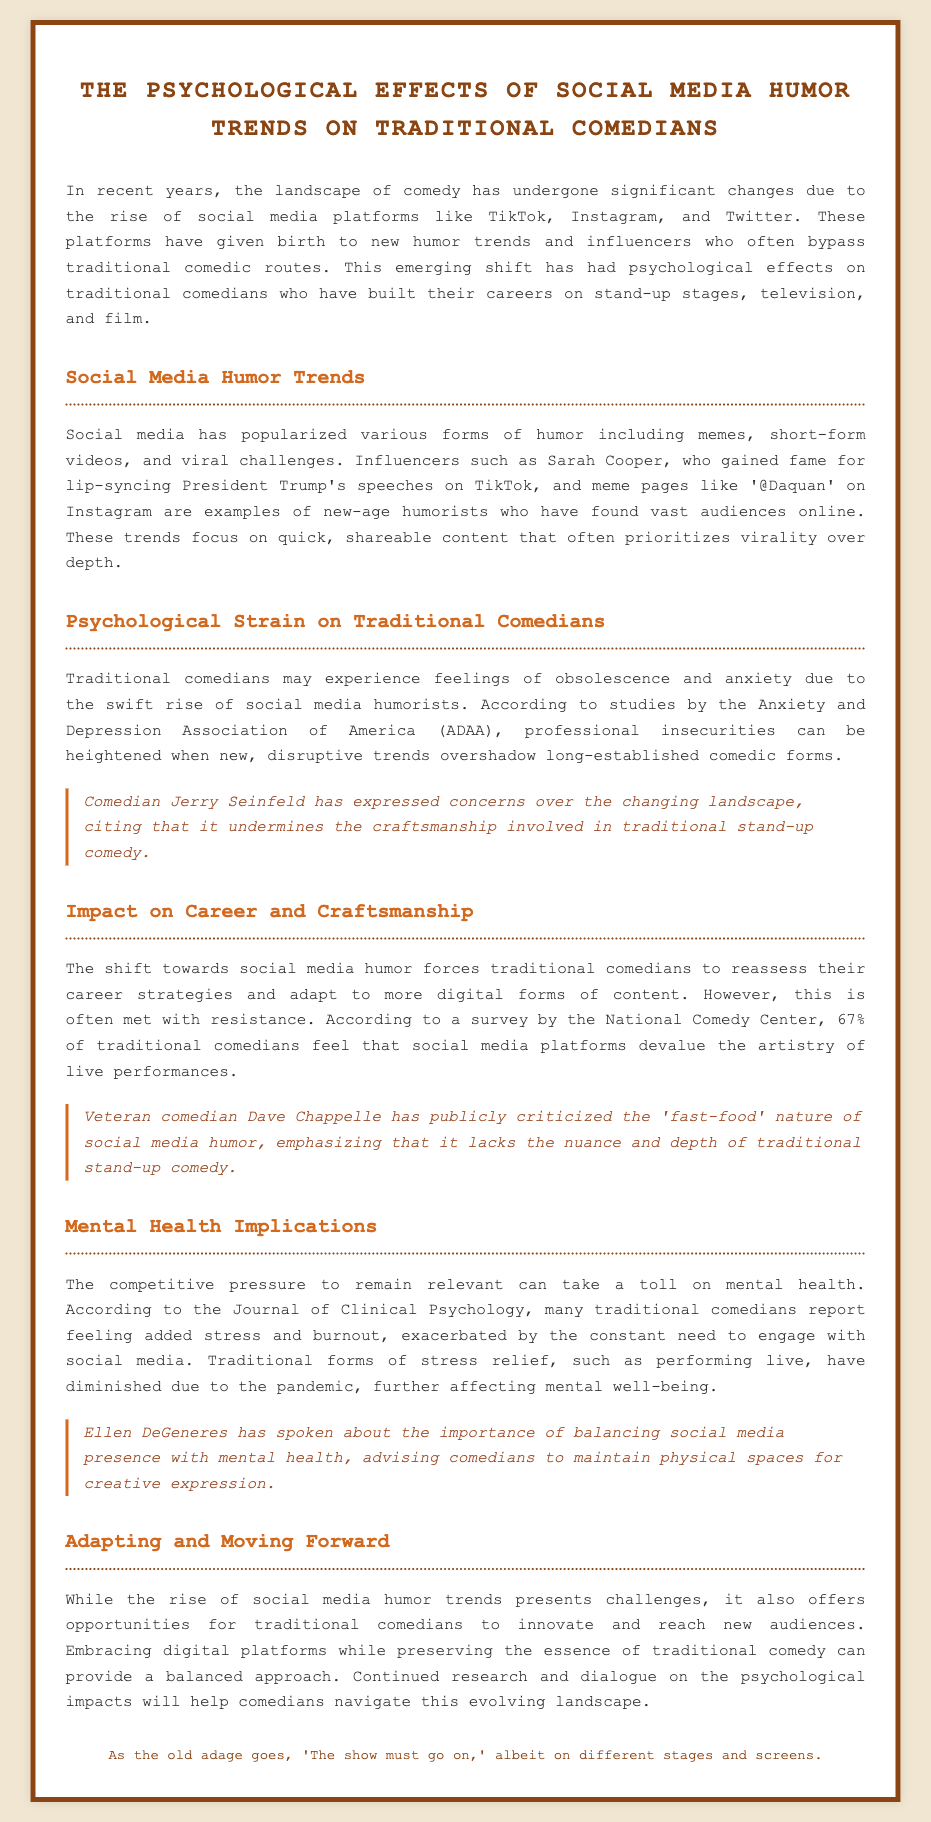What comedian expressed concerns over the changing landscape of comedy? The document mentions Jerry Seinfeld's concerns regarding the impact of social media on traditional stand-up comedy.
Answer: Jerry Seinfeld What percentage of traditional comedians feel that social media devalues their artistry? The National Comedy Center's survey indicates a significant percentage of traditional comedians believe social media devalues live performances.
Answer: 67% What is a psychological effect traditional comedians feel due to social media? According to the studies cited, professional insecurities and feelings of obsolescence are common among traditional comedians due to social media trends.
Answer: Obsolescence Who is an example of a social media humorist mentioned in the document? Sarah Cooper is noted in the document for her rise in humor through social media platforms like TikTok.
Answer: Sarah Cooper What is one implication of the rise of social media humor on mental health? The document discusses how the competitive pressure to remain relevant can lead to increased stress and burnout among traditional comedians.
Answer: Stress What does Ellen DeGeneres advise regarding social media presence? The document references her thoughts on maintaining a balance between social media engagement and mental health for comedians.
Answer: Balance What does Dave Chappelle criticize about social media humor? The document explains that he believes social media humor lacks depth and nuance compared to traditional stand-up.
Answer: Fast-food nature What does the document suggest traditional comedians can do to adapt? It suggests that embracing digital platforms while preserving traditional comedy can help comedians navigate the evolving landscape.
Answer: Innovate 